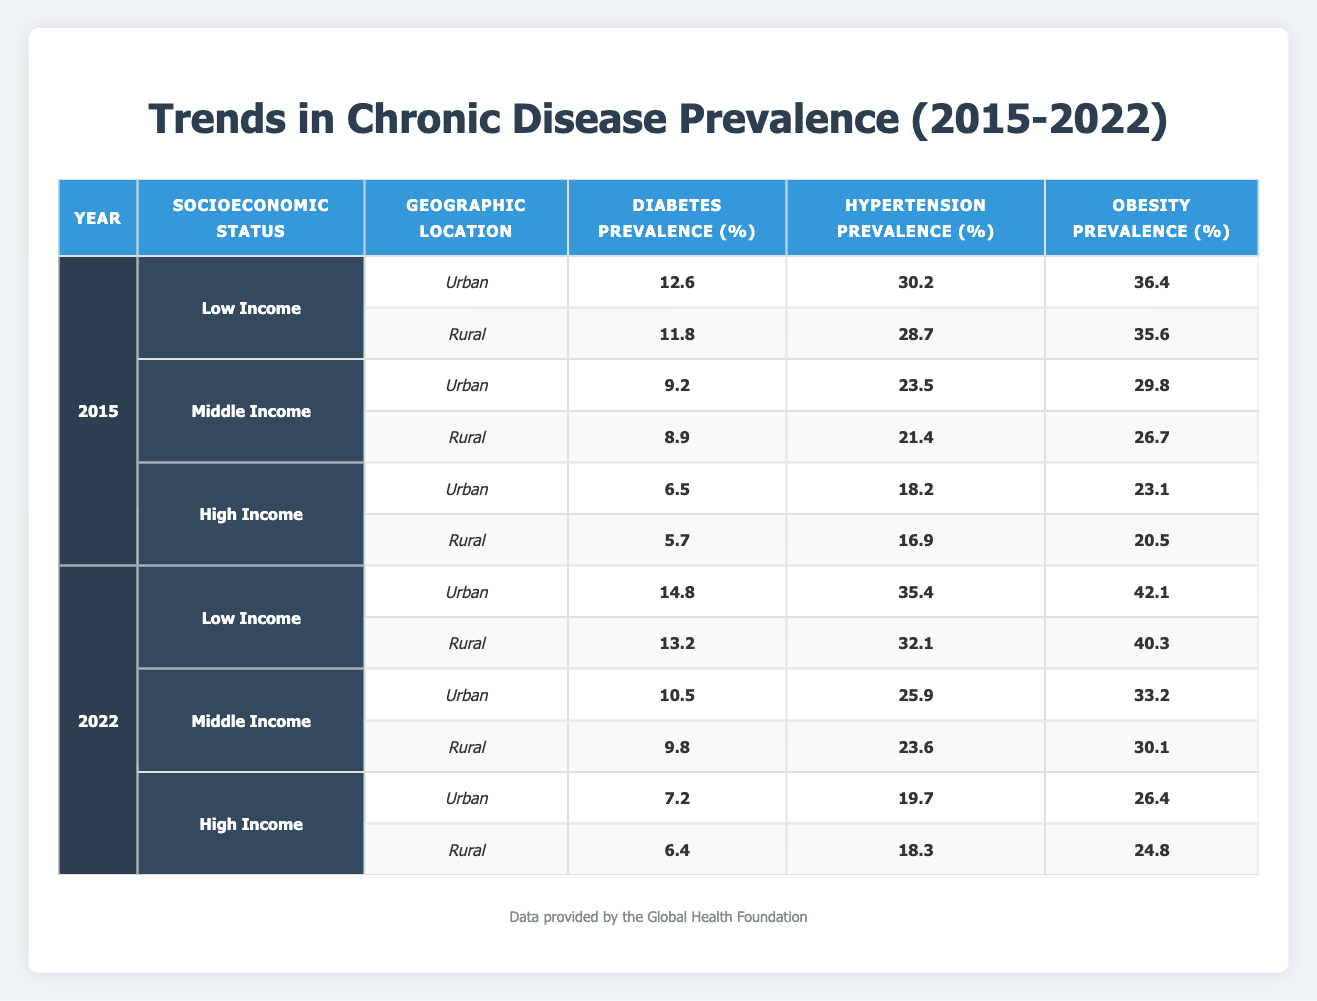What was the diabetes prevalence in rural high-income areas in 2015? In the year 2015, looking at the row corresponding to the rural high-income location, the diabetes prevalence is listed as 5.7%.
Answer: 5.7% What is the obesity prevalence for low-income urban areas in 2022? The table indicates that in 2022, the obesity prevalence for low-income urban areas is 42.1%.
Answer: 42.1% Was the diabetes prevalence higher for rural low-income areas in 2022 compared to urban low-income areas in the same year? In 2022, rural low-income diabetes prevalence is 13.2% while urban low-income diabetes prevalence is 14.8%. Since 13.2% is lower than 14.8%, the statement is false.
Answer: No What is the difference in hypertension prevalence between middle-income urban areas in 2022 and high-income urban areas in 2015? In 2022, the hypertension prevalence for middle-income urban is 25.9%, and for high-income urban in 2015, it is 18.2%. The difference is calculated as 25.9% - 18.2% = 7.7%.
Answer: 7.7% What was the average obesity prevalence across all income levels in urban areas in 2022? The obesity prevalence for urban areas in 2022 is: Low income 42.1% + Middle income 33.2% + High income 26.4% = 101.7%. There are 3 data points, so the average is 101.7% / 3 = 33.9%.
Answer: 33.9% Is the diabetes prevalence in rural middle-income areas higher than the obesity prevalence in middle-income urban areas in 2022? In 2022, the diabetes prevalence for rural middle-income is 9.8% while the obesity prevalence for middle-income urban is 33.2%. Since 9.8% is less than 33.2%, the statement is false.
Answer: No What are the trends in diabetes prevalence for low-income rural areas from 2015 to 2022? The diabetes prevalence for low-income rural areas is 11.8% in 2015 and increases to 13.2% in 2022. This indicates a rising trend in diabetes prevalence for this group over the seven years.
Answer: Increasing Where is the highest prevalence of hypertension found in 2022 among all socioeconomic groups? The highest hypertension prevalence in 2022 is in low-income urban areas at 35.4%, which can be identified by comparing the hypertension percentages across different rows for different groups.
Answer: 35.4% 